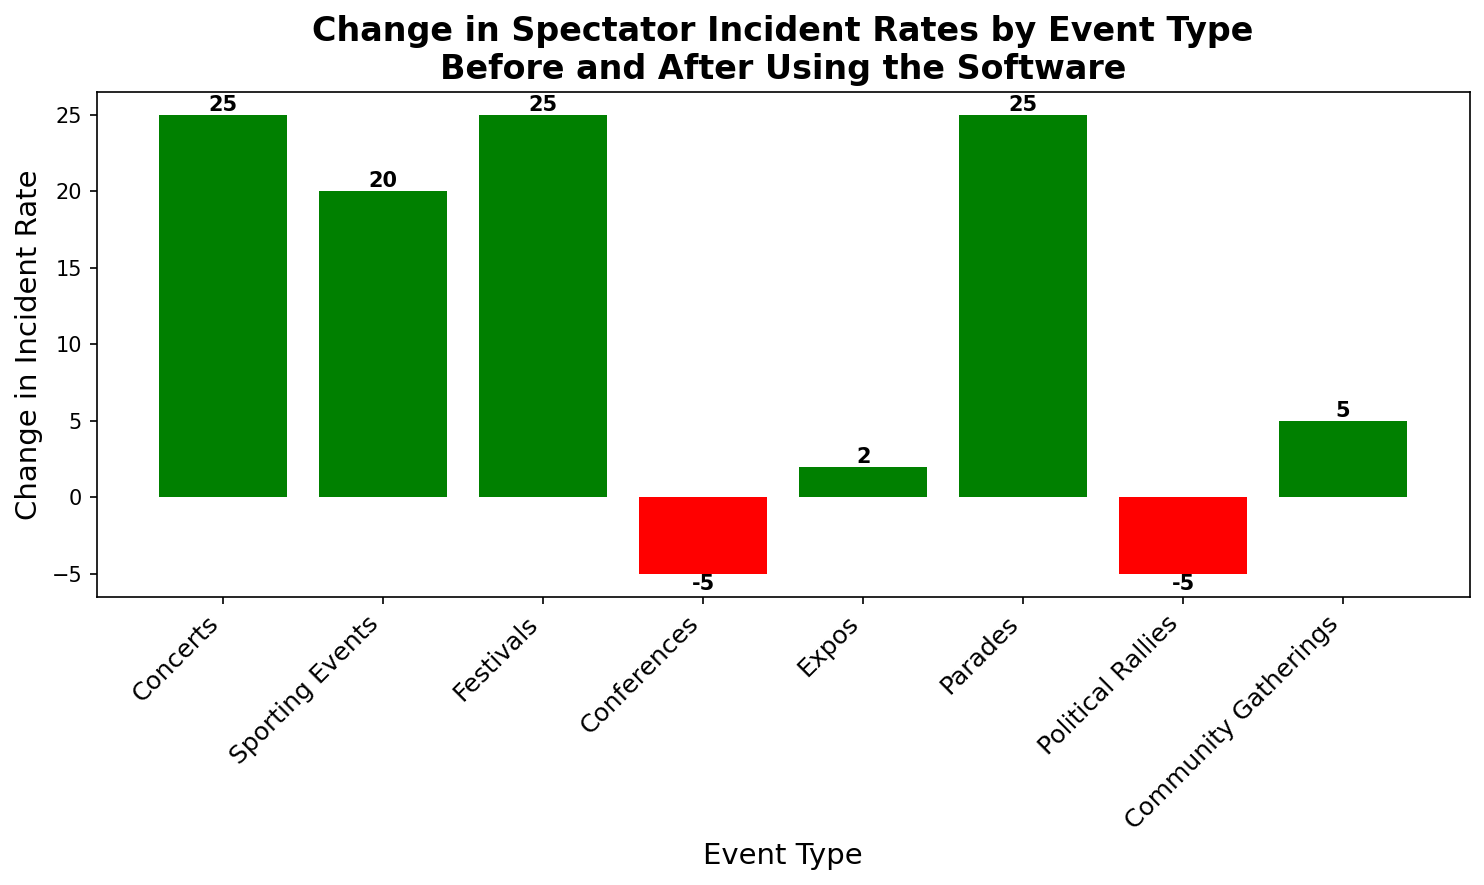Which event type saw the greatest decrease in incidents after using the software? By looking at the height of the green bars, we see that the Concerts, Festivals, and Parades all have the highest decrease in incidents, which is 25.
Answer: Concerts, Festivals, and Parades Which event types experienced an increase in incident rates after using the software? Identify the red bars and read the event types associated with them. These are Conferences and Political Rallies.
Answer: Conferences and Political Rallies What is the net change in incident rates across all events after using the software? Sum all changes in incident rates: 25 (Concerts) + 20 (Sporting Events) + 25 (Festivals) - 5 (Conferences) + 2 (Expos) + 25 (Parades) - 5 (Political Rallies) + 5 (Community Gatherings) = 92.
Answer: 92 Which has a lesser change in incident rate, Expos or Community Gatherings? Compare the heights of the bars for Expos (2) and Community Gatherings (5). Expos is less.
Answer: Expos How does the change in incident rates for Sporting Events compare to that for Conferences? Sporting Events decreased by 20, whereas Conferences increased by 5. Hence, Sporting Events have a greater decrease in incidents compared to the increase in incidents for Conferences.
Answer: Greater decrease What is the average change in incident rate for events where incidents decreased? Identify values for event types with green bars: 25 (Concerts) + 20 (Sporting Events) + 25 (Festivals) + 25 (Parades) + 5 (Community Gatherings), sum these: 25 + 20 + 25 + 25 + 5 = 100, and divide by the number of events: 100/5 = 20.
Answer: 20 Which event type saw a change in incident rate closest to zero after using the software? Among the values, Expos with a change of 2 in incident rate is the closest to zero.
Answer: Expos How many event types had a positive change in incident rates after using the software? Count the number of green bars: Concerts, Sporting Events, Festivals, Parades, Community Gatherings, and Expos. There are 6 such events.
Answer: 6 Calculate the total decrease in incident rates for all event types. Sum all the positive changes in incident rates: 25 (Concerts) + 20 (Sporting Events) + 25 (Festivals) + 25 (Parades) + 5 (Community Gatherings) = 100.
Answer: 100 